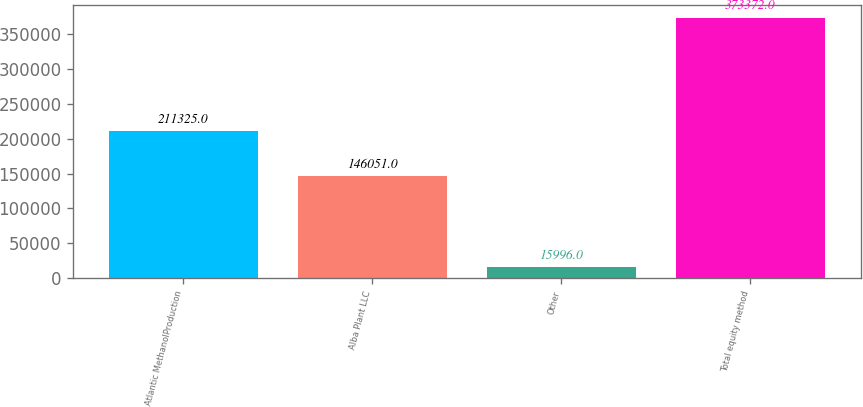<chart> <loc_0><loc_0><loc_500><loc_500><bar_chart><fcel>Atlantic MethanolProduction<fcel>Alba Plant LLC<fcel>Other<fcel>Total equity method<nl><fcel>211325<fcel>146051<fcel>15996<fcel>373372<nl></chart> 